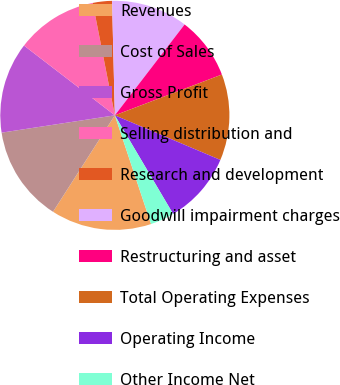Convert chart to OTSL. <chart><loc_0><loc_0><loc_500><loc_500><pie_chart><fcel>Revenues<fcel>Cost of Sales<fcel>Gross Profit<fcel>Selling distribution and<fcel>Research and development<fcel>Goodwill impairment charges<fcel>Restructuring and asset<fcel>Total Operating Expenses<fcel>Operating Income<fcel>Other Income Net<nl><fcel>14.19%<fcel>13.51%<fcel>12.84%<fcel>11.49%<fcel>2.7%<fcel>10.81%<fcel>8.78%<fcel>12.16%<fcel>10.14%<fcel>3.38%<nl></chart> 